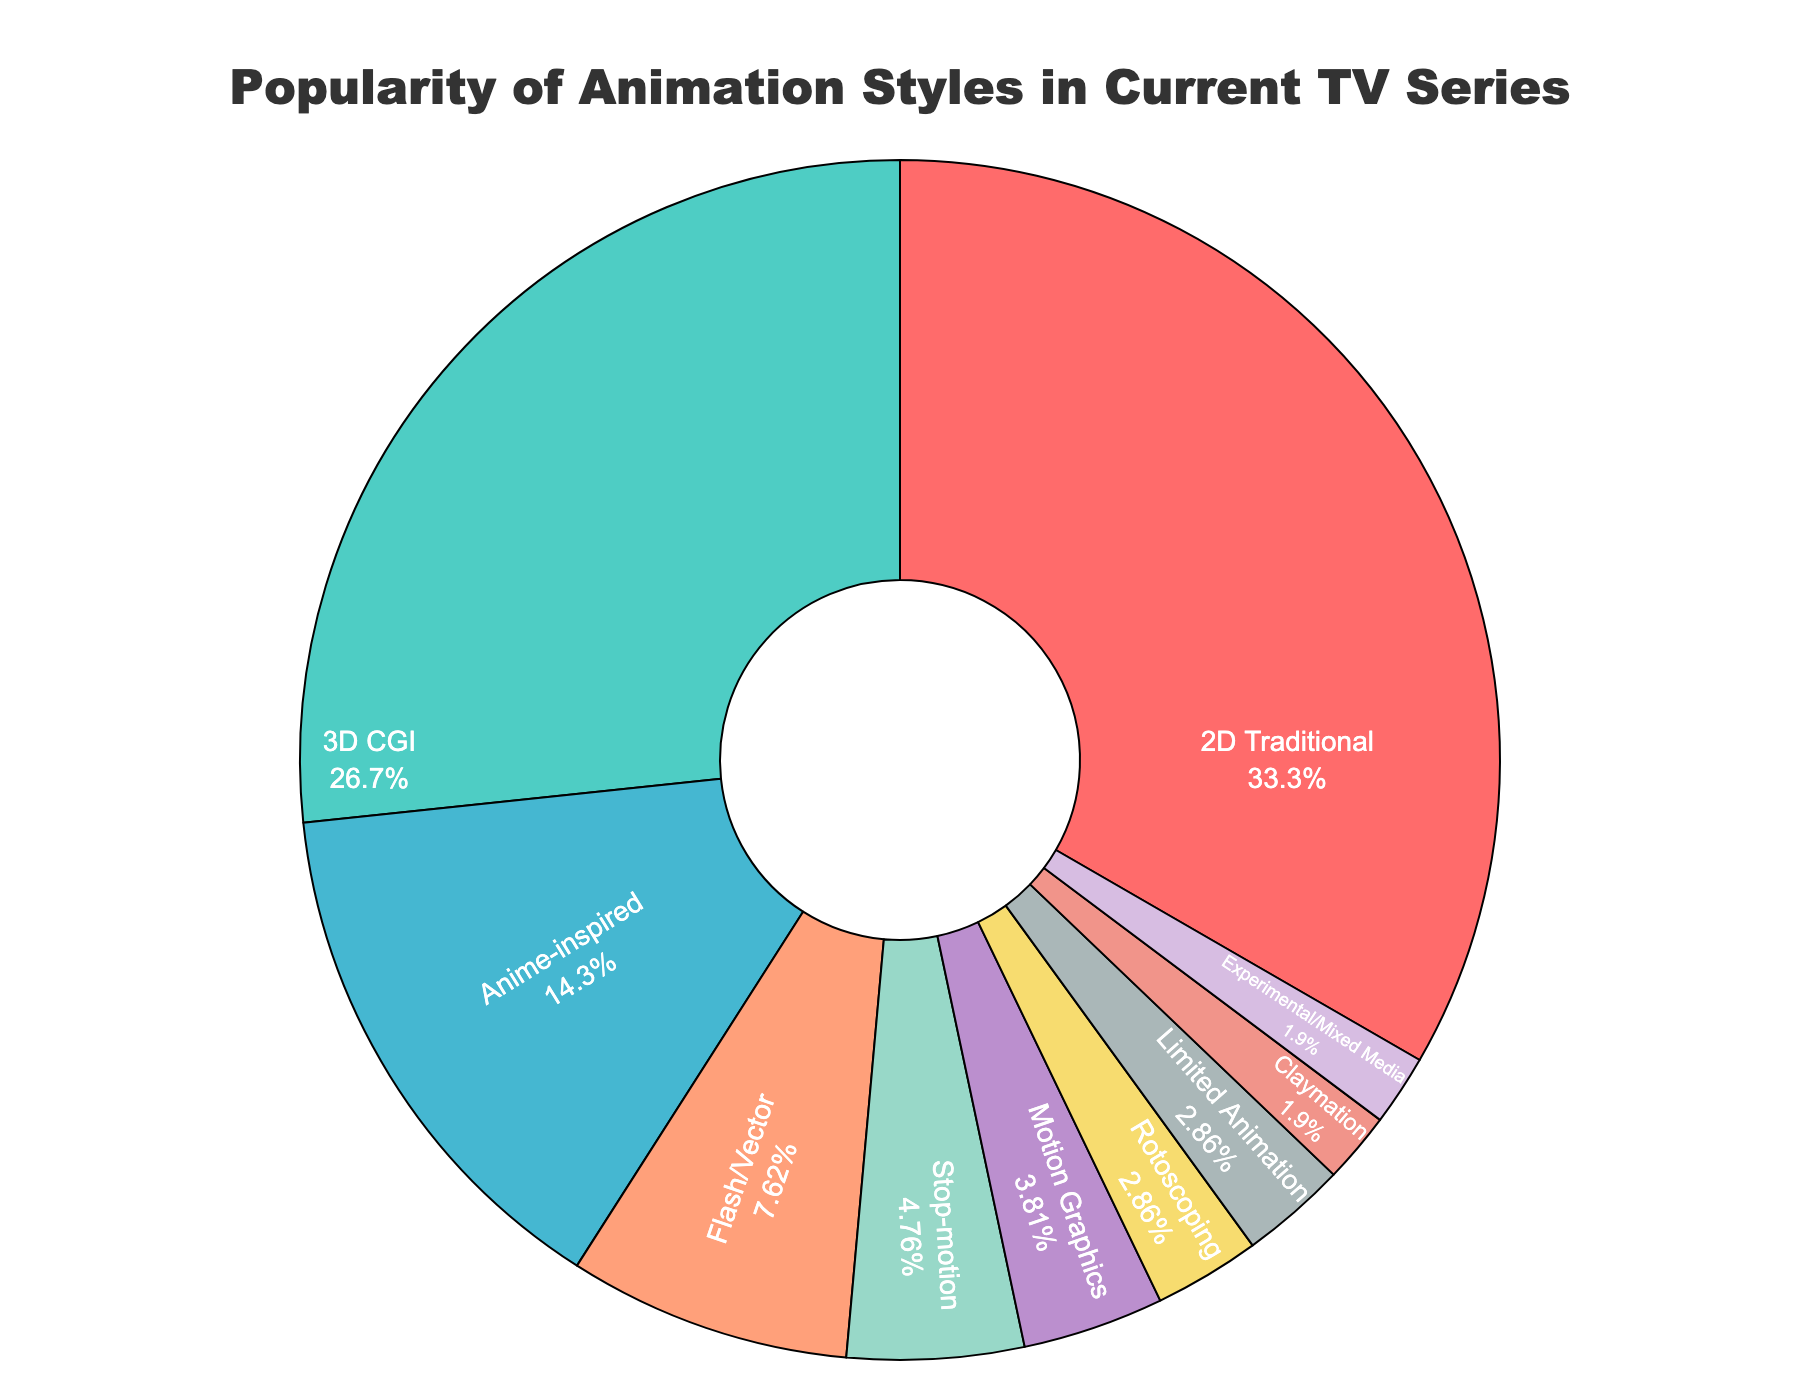What is the most popular animation style in current TV series? The largest portion of the pie chart is dedicated to 2D Traditional animation style, indicating it is the most popular.
Answer: 2D Traditional Which two animation styles together make up more than half of the TV series? Adding the percentages of 2D Traditional (35%) and 3D CGI (28%) gives a total of 63%, which is more than half of the chart.
Answer: 2D Traditional and 3D CGI Which animation style is the least popular in current TV series? The smallest portion of the pie chart corresponds to Claymation and Experimental/Mixed Media, each at 2%.
Answer: Claymation and Experimental/Mixed Media How much more popular is Anime-inspired compared to Motion Graphics in current TV series? Anime-inspired has 15% while Motion Graphics has 4%. Subtracting these values gives 15% - 4% = 11%.
Answer: 11% What percentage of the TV series uses animation styles other than 2D Traditional and 3D CGI? Summing the percentages of 2D Traditional (35%) and 3D CGI (28%) gives 63%. Subtracting this value from 100% gives 100% - 63% = 37%.
Answer: 37% Which animation style has a higher percentage, Flash/Vector or Stop-motion? Flash/Vector has 8% and Stop-motion has 5%, so Flash/Vector has a higher percentage.
Answer: Flash/Vector What are the four least popular animation styles in current TV series? The four least popular styles are Rotoscoping (3%), Motion Graphics (4%), Claymation (2%), and Experimental/Mixed Media (2%).
Answer: Rotoscoping, Motion Graphics, Claymation, Experimental/Mixed Media If you combined the percentages of Stop-motion and Rotoscoping, what would be their total? Adding the percentages of Stop-motion (5%) and Rotoscoping (3%) gives 5% + 3% = 8%.
Answer: 8% How many animation styles have a percentage of 5% or less? Rotoscoping (3%), Motion Graphics (4%), Stop-motion (5%), Claymation (2%), Experimental/Mixed Media (2%), and Limited Animation (3%) all have 5% or less. There are 6 such styles.
Answer: 6 Among the styles with less than 10% popularity, which one is used the most? Among the styles with less than 10% popularity (Flash/Vector, Stop-motion, Rotoscoping, Motion Graphics, Claymation, Experimental/Mixed Media, Limited Animation), Flash/Vector has the highest percentage at 8%.
Answer: Flash/Vector 